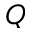Convert formula to latex. <formula><loc_0><loc_0><loc_500><loc_500>Q</formula> 